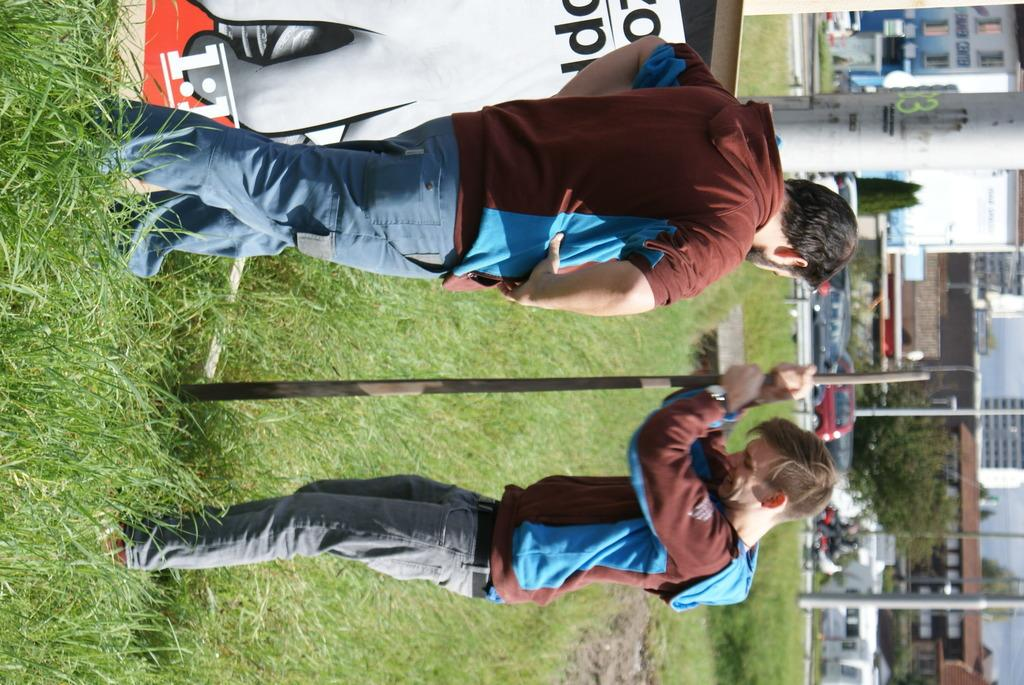How many people are in the image? There are two persons standing in the image. What is one person holding in the image? One person is holding a rod. What type of surface is under the people's feet in the image? There is grass on the ground in the image. What can be seen on the right side of the image? There are buildings, trees, vehicles, and poles on the right side of the image. What type of seat can be seen in the image? There is no seat present in the image. How many giants are visible in the image? There are no giants present in the image. 